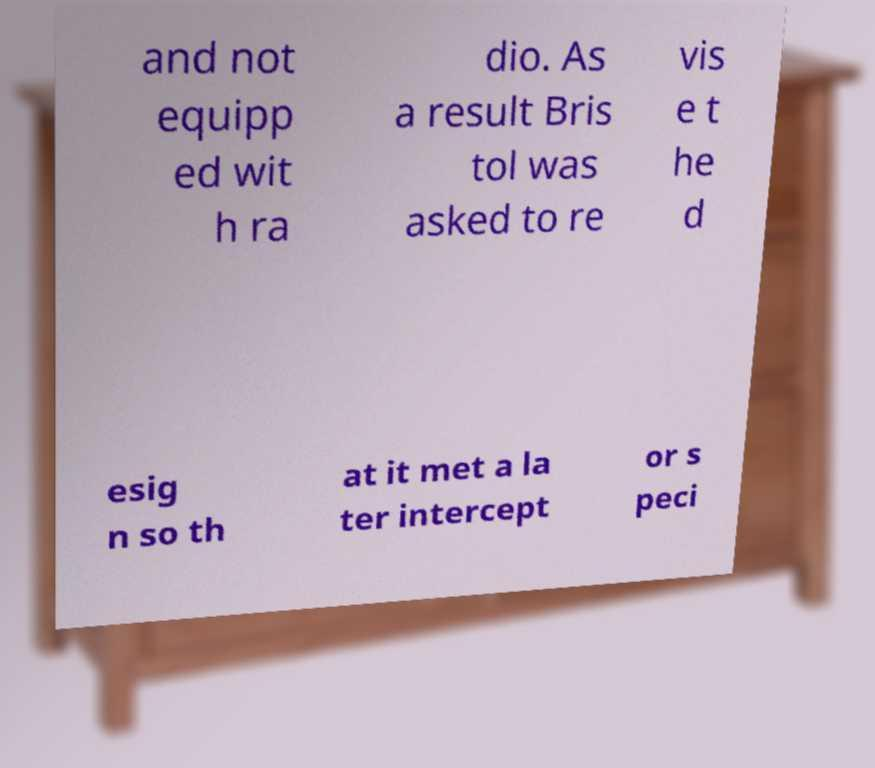Could you extract and type out the text from this image? and not equipp ed wit h ra dio. As a result Bris tol was asked to re vis e t he d esig n so th at it met a la ter intercept or s peci 